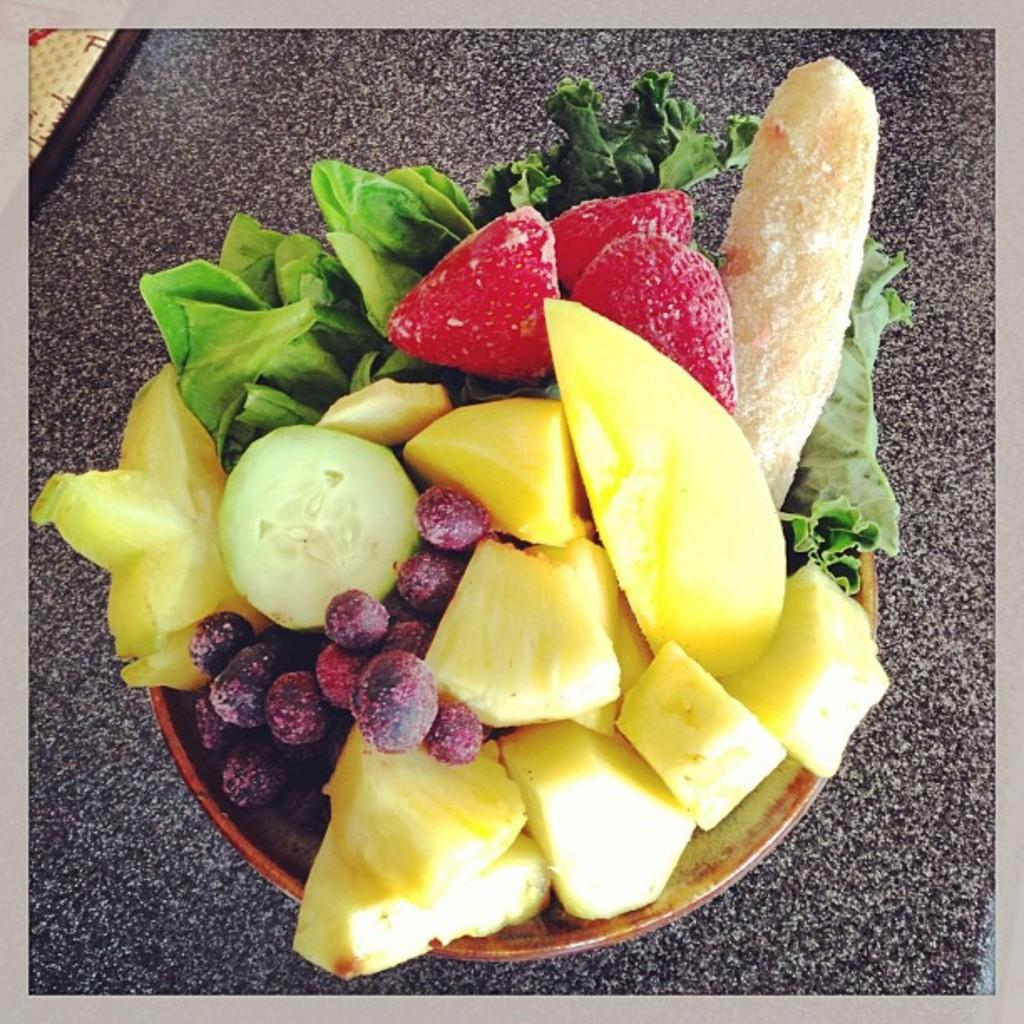What is in the bowl that is visible in the image? The bowl contains cut fruits. What specific fruits can be seen in the bowl? Grapes and strawberries are present in the bowl. Are there any other types of food in the bowl? Yes, leafy vegetables are present in the bowl. What color is the sky in the image? There is no sky visible in the image; it is focused on the contents of the bowl. Is there a rainstorm happening in the image? There is no rainstorm present in the image; it is focused on the contents of the bowl. 